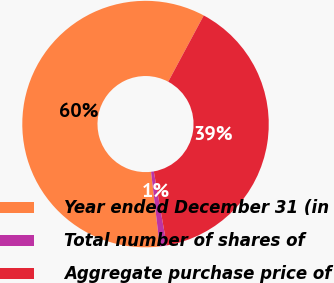Convert chart to OTSL. <chart><loc_0><loc_0><loc_500><loc_500><pie_chart><fcel>Year ended December 31 (in<fcel>Total number of shares of<fcel>Aggregate purchase price of<nl><fcel>59.67%<fcel>0.92%<fcel>39.41%<nl></chart> 